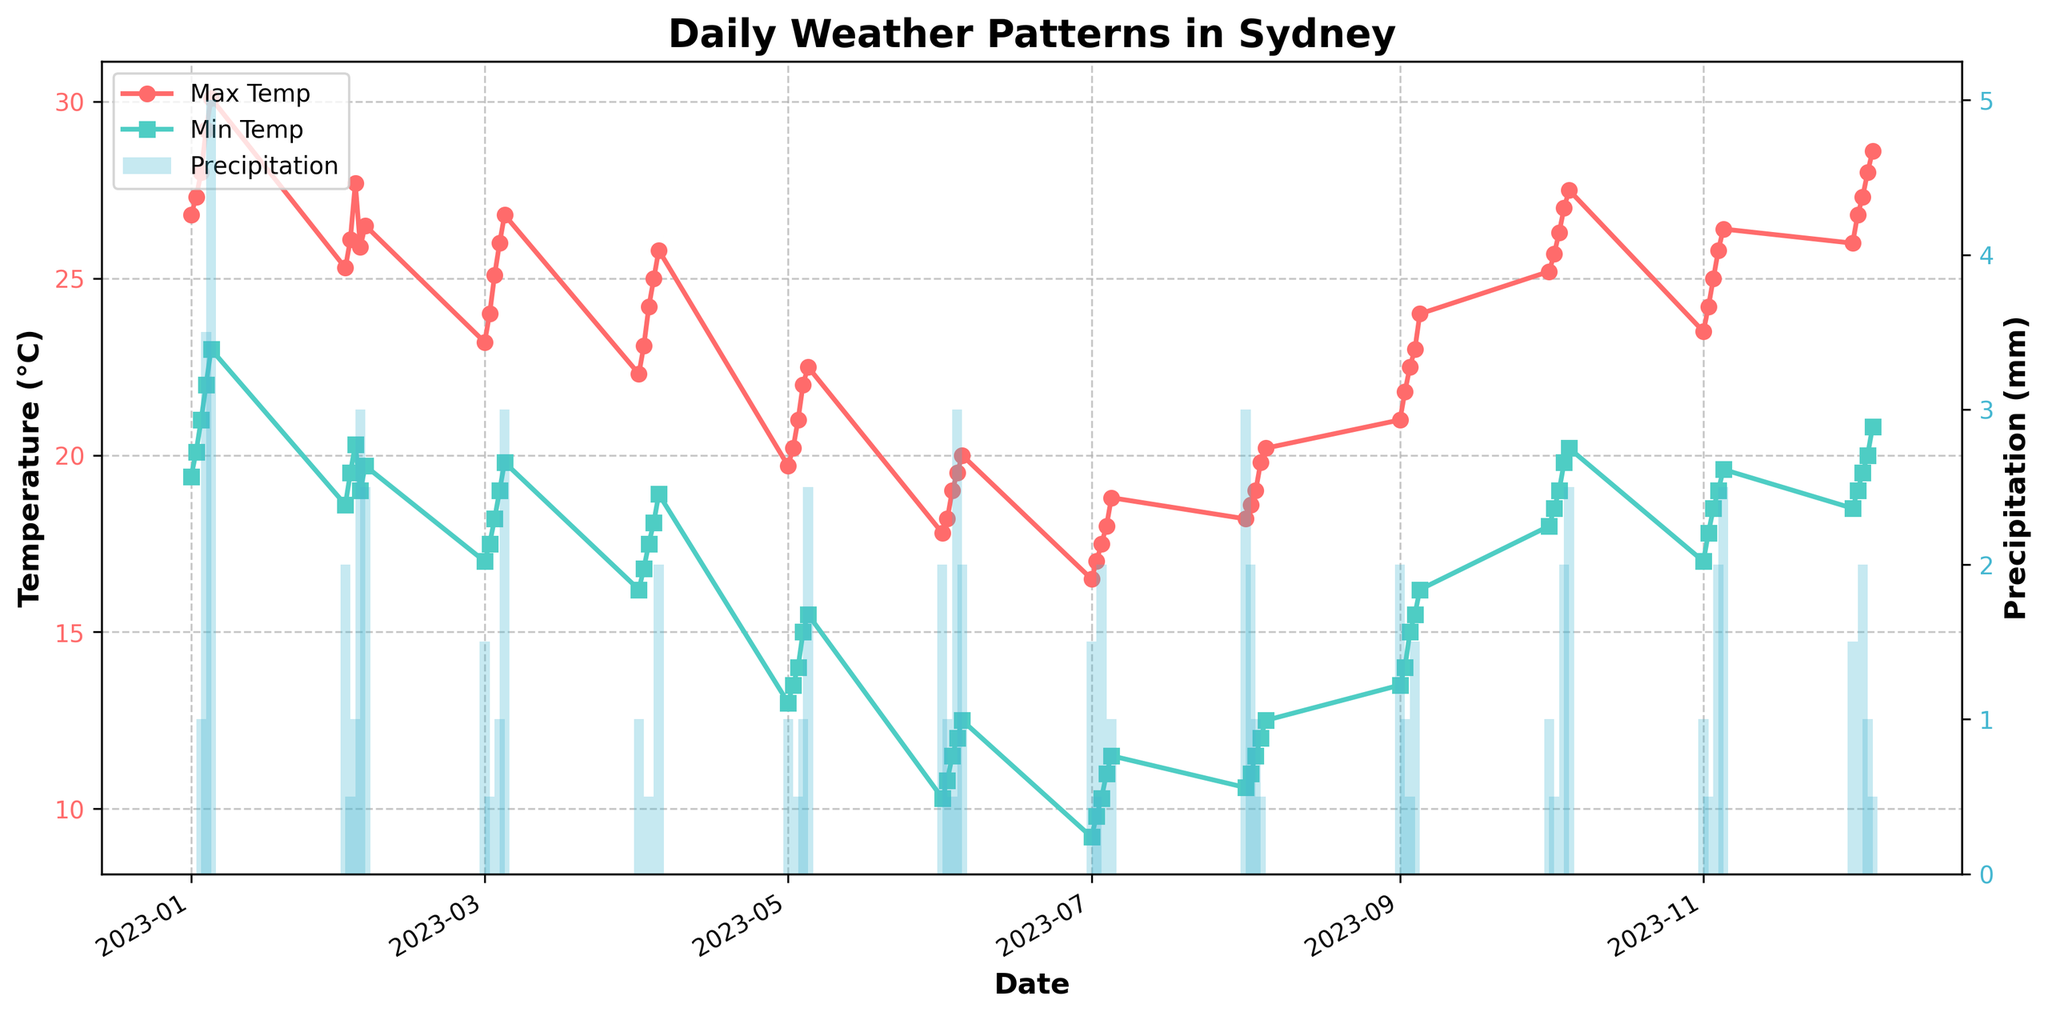What is the title of the figure? The title is usually located at the top center of the figure. Looking at that, we can see that it reads "Daily Weather Patterns in Sydney".
Answer: Daily Weather Patterns in Sydney What are the labels of the two y-axes? Looking at each y-axis label, we see that the left y-axis (y1) is labeled "Temperature (°C)" and the right y-axis (y2) is labeled "Precipitation (mm)".
Answer: Temperature (°C) and Precipitation (mm) Which month has the highest maximum temperature recorded? Observing each month’s maximum temperature data plotted on the figure, we see that January has the highest point comparing all months.
Answer: January On which date was the highest precipitation recorded, and how much was it? By looking at the tallest bar representing precipitation in the plot, we identify the date as January 5th with a precipitation level of 5.0 mm.
Answer: January 5th, 5.0 mm Between which months do we see a noticeable decrease in temperature? Observing the temperature trends over the months, there is a significant drop in temperatures between March and July.
Answer: March to July What is the range of daily maximum temperatures in August? By finding the highest and lowest maximum temperature points within August, we identify that the range is from 18.2°C to 20.2°C.
Answer: 18.2°C to 20.2°C Which month has the highest average sunshine hours? To determine the month, we should visually estimate the average sunshine hours for each month. December appears with consistently long sunshine hour bars that seem the highest on average.
Answer: December How does the minimum temperature in December compare to July? From the plot, July’s minimum temperatures are significantly lower than those in December, which are around 18.5°C.
Answer: December > July What’s the average maximum temperature in October? By summarizing and averaging the maximum temperatures recorded in October: (25.2 + 25.7 + 26.3 + 27.0 + 27.5) / 5 = 26.34°C.
Answer: 26.34°C 